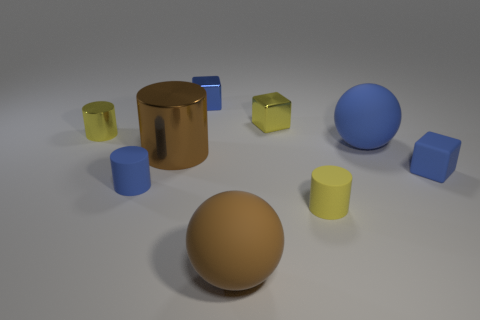There is a ball that is the same color as the rubber block; what size is it?
Provide a succinct answer. Large. There is a small rubber cylinder that is on the left side of the brown matte thing; is its color the same as the small matte block?
Ensure brevity in your answer.  Yes. Does the block that is on the right side of the large blue sphere have the same size as the brown cylinder left of the big brown matte object?
Your response must be concise. No. How many objects are matte cylinders that are to the right of the tiny blue matte cylinder or small rubber objects?
Ensure brevity in your answer.  3. What is the material of the small yellow block?
Make the answer very short. Metal. Is the brown sphere the same size as the brown metal object?
Provide a short and direct response. Yes. How many blocks are either purple shiny things or matte things?
Provide a succinct answer. 1. There is a tiny rubber cylinder in front of the small blue rubber object that is to the left of the small blue matte block; what is its color?
Offer a terse response. Yellow. Are there fewer small cylinders that are on the left side of the tiny yellow matte thing than cylinders left of the tiny yellow block?
Provide a succinct answer. Yes. There is a blue rubber ball; is its size the same as the blue matte thing that is left of the yellow rubber object?
Your response must be concise. No. 